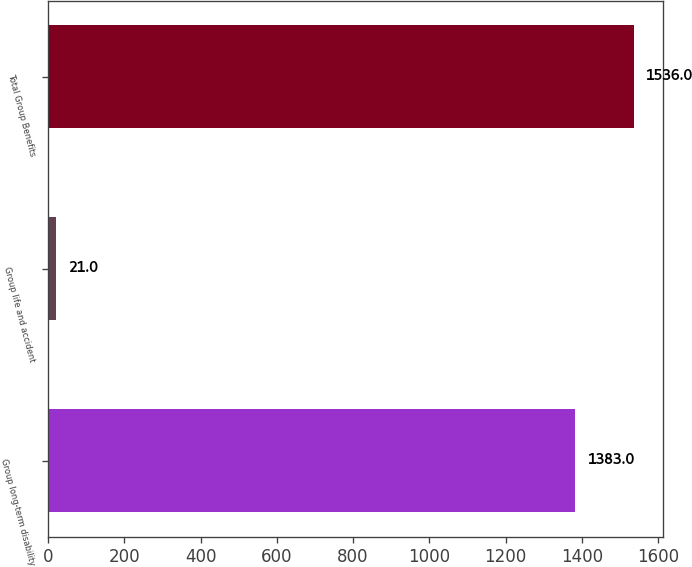<chart> <loc_0><loc_0><loc_500><loc_500><bar_chart><fcel>Group long-term disability<fcel>Group life and accident<fcel>Total Group Benefits<nl><fcel>1383<fcel>21<fcel>1536<nl></chart> 